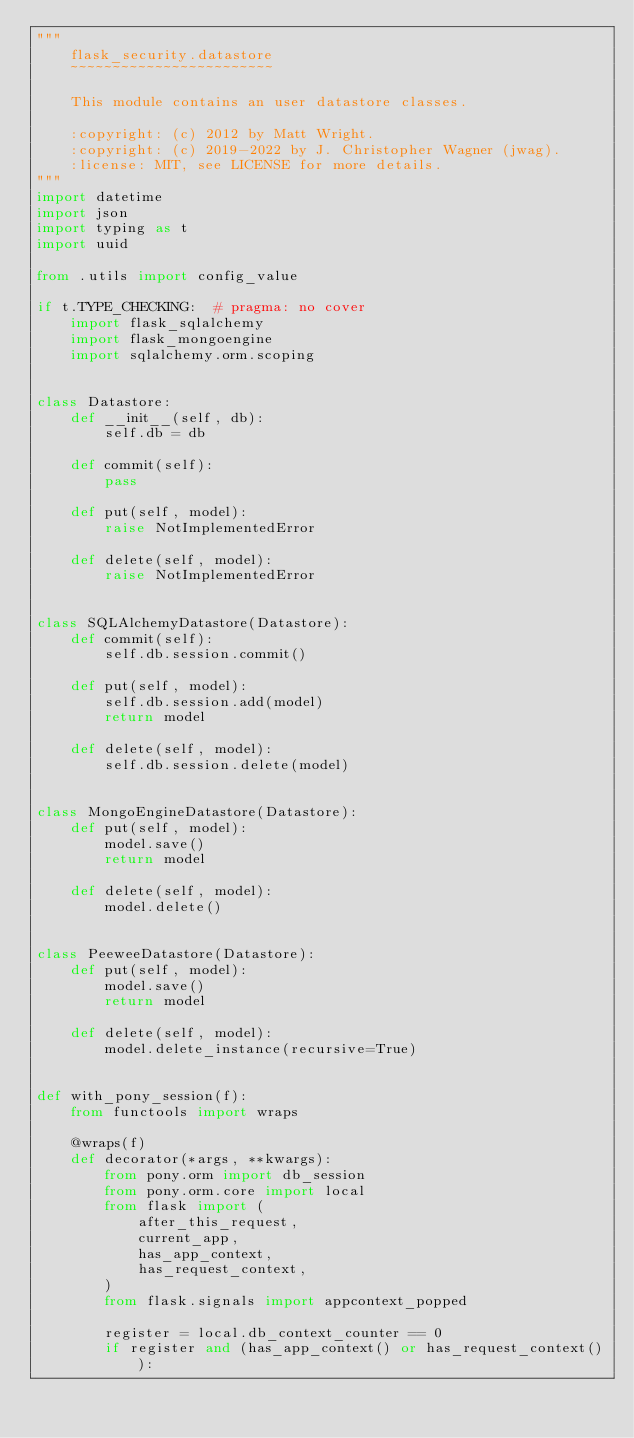<code> <loc_0><loc_0><loc_500><loc_500><_Python_>"""
    flask_security.datastore
    ~~~~~~~~~~~~~~~~~~~~~~~~

    This module contains an user datastore classes.

    :copyright: (c) 2012 by Matt Wright.
    :copyright: (c) 2019-2022 by J. Christopher Wagner (jwag).
    :license: MIT, see LICENSE for more details.
"""
import datetime
import json
import typing as t
import uuid

from .utils import config_value

if t.TYPE_CHECKING:  # pragma: no cover
    import flask_sqlalchemy
    import flask_mongoengine
    import sqlalchemy.orm.scoping


class Datastore:
    def __init__(self, db):
        self.db = db

    def commit(self):
        pass

    def put(self, model):
        raise NotImplementedError

    def delete(self, model):
        raise NotImplementedError


class SQLAlchemyDatastore(Datastore):
    def commit(self):
        self.db.session.commit()

    def put(self, model):
        self.db.session.add(model)
        return model

    def delete(self, model):
        self.db.session.delete(model)


class MongoEngineDatastore(Datastore):
    def put(self, model):
        model.save()
        return model

    def delete(self, model):
        model.delete()


class PeeweeDatastore(Datastore):
    def put(self, model):
        model.save()
        return model

    def delete(self, model):
        model.delete_instance(recursive=True)


def with_pony_session(f):
    from functools import wraps

    @wraps(f)
    def decorator(*args, **kwargs):
        from pony.orm import db_session
        from pony.orm.core import local
        from flask import (
            after_this_request,
            current_app,
            has_app_context,
            has_request_context,
        )
        from flask.signals import appcontext_popped

        register = local.db_context_counter == 0
        if register and (has_app_context() or has_request_context()):</code> 